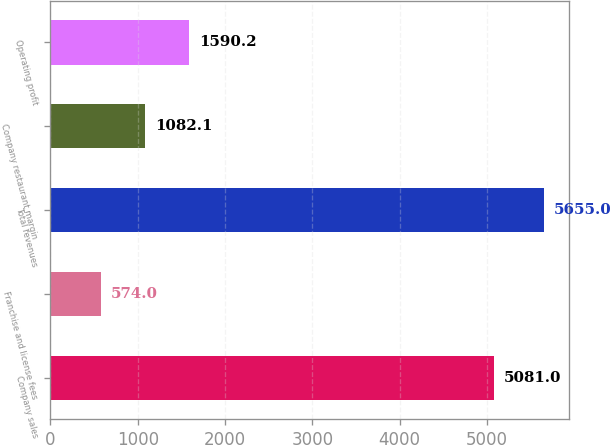Convert chart. <chart><loc_0><loc_0><loc_500><loc_500><bar_chart><fcel>Company sales<fcel>Franchise and license fees<fcel>Total revenues<fcel>Company restaurant margin<fcel>Operating profit<nl><fcel>5081<fcel>574<fcel>5655<fcel>1082.1<fcel>1590.2<nl></chart> 